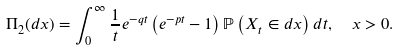<formula> <loc_0><loc_0><loc_500><loc_500>\Pi _ { 2 } ( d x ) = \int _ { 0 } ^ { \infty } \frac { 1 } { t } e ^ { - q t } \left ( e ^ { - p t } - 1 \right ) \mathbb { P } \left ( X _ { t } \in d x \right ) d t , \ \ x > 0 .</formula> 